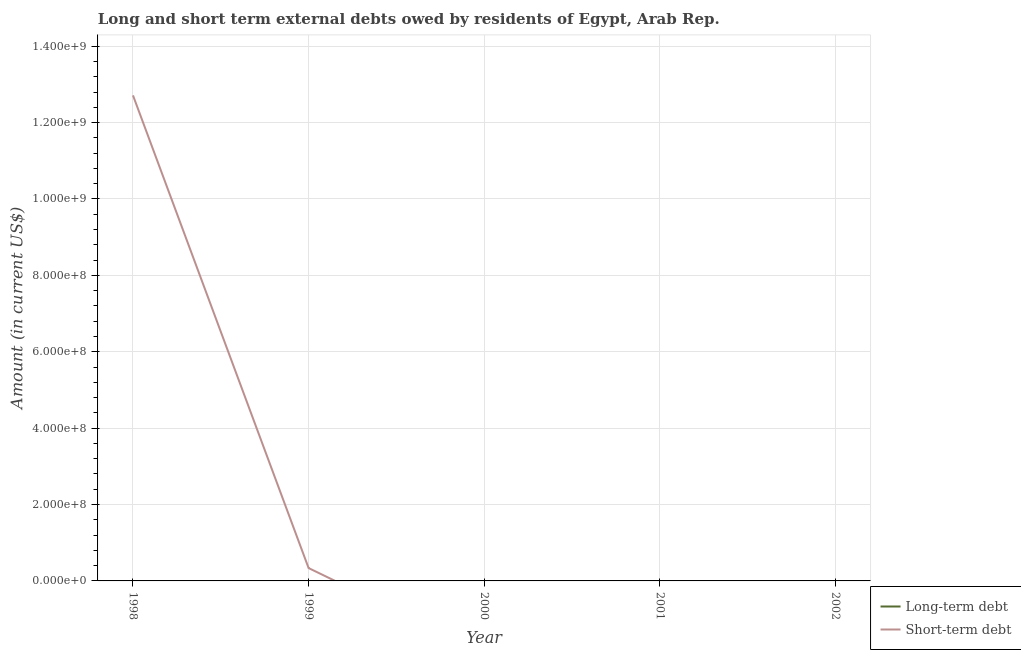Is the number of lines equal to the number of legend labels?
Provide a short and direct response. No. What is the long-term debts owed by residents in 2002?
Your answer should be very brief. 0. Across all years, what is the maximum short-term debts owed by residents?
Provide a short and direct response. 1.27e+09. In which year was the short-term debts owed by residents maximum?
Offer a very short reply. 1998. What is the total short-term debts owed by residents in the graph?
Keep it short and to the point. 1.30e+09. In how many years, is the short-term debts owed by residents greater than 920000000 US$?
Your answer should be very brief. 1. What is the ratio of the short-term debts owed by residents in 1998 to that in 1999?
Your answer should be very brief. 37.72. What is the difference between the highest and the lowest short-term debts owed by residents?
Give a very brief answer. 1.27e+09. In how many years, is the short-term debts owed by residents greater than the average short-term debts owed by residents taken over all years?
Your answer should be compact. 1. How many lines are there?
Offer a terse response. 1. Are the values on the major ticks of Y-axis written in scientific E-notation?
Provide a succinct answer. Yes. How are the legend labels stacked?
Keep it short and to the point. Vertical. What is the title of the graph?
Ensure brevity in your answer.  Long and short term external debts owed by residents of Egypt, Arab Rep. What is the label or title of the X-axis?
Your answer should be very brief. Year. What is the label or title of the Y-axis?
Make the answer very short. Amount (in current US$). What is the Amount (in current US$) of Long-term debt in 1998?
Offer a very short reply. 0. What is the Amount (in current US$) in Short-term debt in 1998?
Give a very brief answer. 1.27e+09. What is the Amount (in current US$) in Long-term debt in 1999?
Provide a short and direct response. 0. What is the Amount (in current US$) in Short-term debt in 1999?
Keep it short and to the point. 3.37e+07. What is the Amount (in current US$) in Short-term debt in 2000?
Ensure brevity in your answer.  0. What is the Amount (in current US$) in Long-term debt in 2001?
Offer a terse response. 0. What is the Amount (in current US$) in Short-term debt in 2001?
Keep it short and to the point. 0. Across all years, what is the maximum Amount (in current US$) of Short-term debt?
Your answer should be very brief. 1.27e+09. What is the total Amount (in current US$) of Long-term debt in the graph?
Offer a terse response. 0. What is the total Amount (in current US$) of Short-term debt in the graph?
Your answer should be very brief. 1.30e+09. What is the difference between the Amount (in current US$) in Short-term debt in 1998 and that in 1999?
Your response must be concise. 1.24e+09. What is the average Amount (in current US$) of Long-term debt per year?
Ensure brevity in your answer.  0. What is the average Amount (in current US$) of Short-term debt per year?
Offer a very short reply. 2.61e+08. What is the ratio of the Amount (in current US$) in Short-term debt in 1998 to that in 1999?
Make the answer very short. 37.72. What is the difference between the highest and the lowest Amount (in current US$) in Short-term debt?
Offer a terse response. 1.27e+09. 